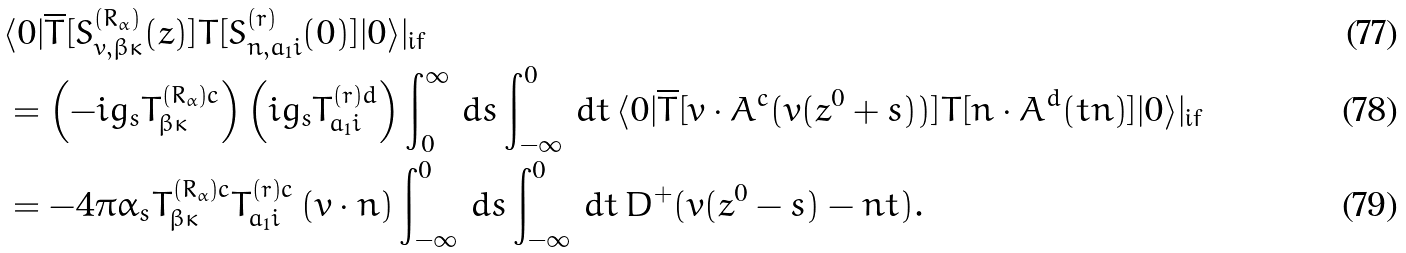<formula> <loc_0><loc_0><loc_500><loc_500>& \langle 0 | \overline { T } [ S ^ { ( R _ { \alpha } ) } _ { v , \beta \kappa } ( z ) ] T [ S ^ { ( r ) } _ { n , a _ { 1 } i } ( 0 ) ] | 0 \rangle | _ { \text {if} } \\ & = \left ( - i g _ { s } { T } ^ { ( R _ { \alpha } ) c } _ { \beta \kappa } \right ) \left ( i g _ { s } { T } ^ { ( r ) d } _ { a _ { 1 } i } \right ) \int _ { 0 } ^ { \infty } \, d s \int _ { - \infty } ^ { 0 } \, d t \, \langle 0 | \overline { T } [ v \cdot A ^ { c } ( v ( z ^ { 0 } + s ) ) ] T [ n \cdot A ^ { d } ( t n ) ] | 0 \rangle | _ { \text {if} } \\ & = - 4 \pi \alpha _ { s } { T } ^ { ( R _ { \alpha } ) c } _ { \beta \kappa } { T } ^ { ( r ) c } _ { a _ { 1 } i } \, ( v \cdot n ) \int _ { - \infty } ^ { 0 } \, d s \int _ { - \infty } ^ { 0 } \, d t \, D ^ { + } ( v ( z ^ { 0 } - s ) - n t ) .</formula> 